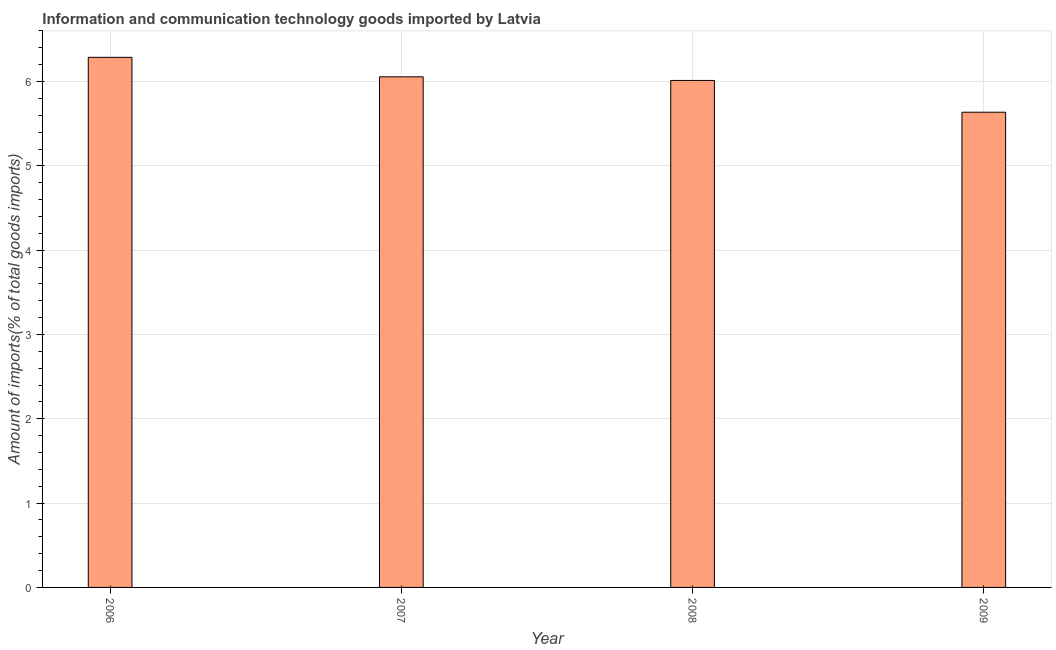Does the graph contain any zero values?
Ensure brevity in your answer.  No. What is the title of the graph?
Your response must be concise. Information and communication technology goods imported by Latvia. What is the label or title of the Y-axis?
Your response must be concise. Amount of imports(% of total goods imports). What is the amount of ict goods imports in 2009?
Give a very brief answer. 5.64. Across all years, what is the maximum amount of ict goods imports?
Make the answer very short. 6.29. Across all years, what is the minimum amount of ict goods imports?
Provide a succinct answer. 5.64. In which year was the amount of ict goods imports maximum?
Offer a terse response. 2006. In which year was the amount of ict goods imports minimum?
Make the answer very short. 2009. What is the sum of the amount of ict goods imports?
Your answer should be compact. 23.99. What is the difference between the amount of ict goods imports in 2008 and 2009?
Offer a very short reply. 0.38. What is the average amount of ict goods imports per year?
Keep it short and to the point. 6. What is the median amount of ict goods imports?
Offer a terse response. 6.03. Do a majority of the years between 2008 and 2007 (inclusive) have amount of ict goods imports greater than 0.4 %?
Offer a very short reply. No. What is the ratio of the amount of ict goods imports in 2006 to that in 2009?
Keep it short and to the point. 1.11. Is the amount of ict goods imports in 2006 less than that in 2007?
Make the answer very short. No. Is the difference between the amount of ict goods imports in 2006 and 2009 greater than the difference between any two years?
Give a very brief answer. Yes. What is the difference between the highest and the second highest amount of ict goods imports?
Keep it short and to the point. 0.23. What is the difference between the highest and the lowest amount of ict goods imports?
Offer a very short reply. 0.65. In how many years, is the amount of ict goods imports greater than the average amount of ict goods imports taken over all years?
Your response must be concise. 3. Are all the bars in the graph horizontal?
Make the answer very short. No. What is the Amount of imports(% of total goods imports) of 2006?
Ensure brevity in your answer.  6.29. What is the Amount of imports(% of total goods imports) of 2007?
Offer a very short reply. 6.06. What is the Amount of imports(% of total goods imports) in 2008?
Your response must be concise. 6.01. What is the Amount of imports(% of total goods imports) in 2009?
Ensure brevity in your answer.  5.64. What is the difference between the Amount of imports(% of total goods imports) in 2006 and 2007?
Keep it short and to the point. 0.23. What is the difference between the Amount of imports(% of total goods imports) in 2006 and 2008?
Your answer should be compact. 0.27. What is the difference between the Amount of imports(% of total goods imports) in 2006 and 2009?
Offer a very short reply. 0.65. What is the difference between the Amount of imports(% of total goods imports) in 2007 and 2008?
Offer a terse response. 0.04. What is the difference between the Amount of imports(% of total goods imports) in 2007 and 2009?
Give a very brief answer. 0.42. What is the difference between the Amount of imports(% of total goods imports) in 2008 and 2009?
Offer a very short reply. 0.38. What is the ratio of the Amount of imports(% of total goods imports) in 2006 to that in 2007?
Keep it short and to the point. 1.04. What is the ratio of the Amount of imports(% of total goods imports) in 2006 to that in 2008?
Provide a short and direct response. 1.05. What is the ratio of the Amount of imports(% of total goods imports) in 2006 to that in 2009?
Provide a succinct answer. 1.11. What is the ratio of the Amount of imports(% of total goods imports) in 2007 to that in 2009?
Keep it short and to the point. 1.07. What is the ratio of the Amount of imports(% of total goods imports) in 2008 to that in 2009?
Offer a very short reply. 1.07. 